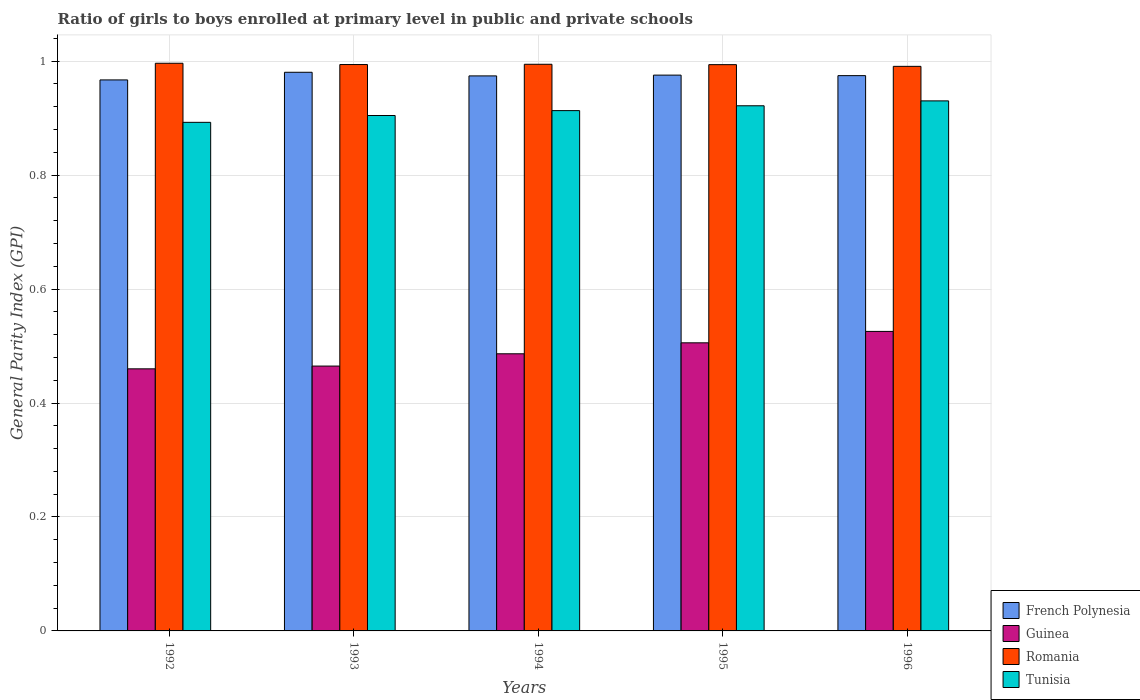How many groups of bars are there?
Offer a terse response. 5. Are the number of bars per tick equal to the number of legend labels?
Provide a succinct answer. Yes. Are the number of bars on each tick of the X-axis equal?
Your answer should be very brief. Yes. How many bars are there on the 3rd tick from the left?
Keep it short and to the point. 4. What is the label of the 3rd group of bars from the left?
Your answer should be very brief. 1994. What is the general parity index in French Polynesia in 1995?
Your answer should be compact. 0.98. Across all years, what is the maximum general parity index in French Polynesia?
Provide a short and direct response. 0.98. Across all years, what is the minimum general parity index in Guinea?
Make the answer very short. 0.46. What is the total general parity index in French Polynesia in the graph?
Your answer should be compact. 4.87. What is the difference between the general parity index in Guinea in 1993 and that in 1994?
Make the answer very short. -0.02. What is the difference between the general parity index in Guinea in 1994 and the general parity index in Tunisia in 1995?
Give a very brief answer. -0.44. What is the average general parity index in Tunisia per year?
Give a very brief answer. 0.91. In the year 1995, what is the difference between the general parity index in French Polynesia and general parity index in Tunisia?
Your answer should be very brief. 0.05. What is the ratio of the general parity index in Romania in 1993 to that in 1996?
Keep it short and to the point. 1. What is the difference between the highest and the second highest general parity index in French Polynesia?
Provide a short and direct response. 0. What is the difference between the highest and the lowest general parity index in Tunisia?
Your response must be concise. 0.04. Is the sum of the general parity index in Guinea in 1993 and 1996 greater than the maximum general parity index in Tunisia across all years?
Provide a succinct answer. Yes. Is it the case that in every year, the sum of the general parity index in Romania and general parity index in French Polynesia is greater than the sum of general parity index in Tunisia and general parity index in Guinea?
Your answer should be very brief. Yes. What does the 4th bar from the left in 1995 represents?
Make the answer very short. Tunisia. What does the 4th bar from the right in 1992 represents?
Ensure brevity in your answer.  French Polynesia. Is it the case that in every year, the sum of the general parity index in French Polynesia and general parity index in Guinea is greater than the general parity index in Tunisia?
Make the answer very short. Yes. How many bars are there?
Make the answer very short. 20. How many years are there in the graph?
Your answer should be compact. 5. What is the difference between two consecutive major ticks on the Y-axis?
Give a very brief answer. 0.2. Are the values on the major ticks of Y-axis written in scientific E-notation?
Offer a terse response. No. Does the graph contain any zero values?
Provide a succinct answer. No. Does the graph contain grids?
Your response must be concise. Yes. Where does the legend appear in the graph?
Make the answer very short. Bottom right. How many legend labels are there?
Your response must be concise. 4. How are the legend labels stacked?
Your answer should be compact. Vertical. What is the title of the graph?
Keep it short and to the point. Ratio of girls to boys enrolled at primary level in public and private schools. Does "Tunisia" appear as one of the legend labels in the graph?
Offer a very short reply. Yes. What is the label or title of the X-axis?
Offer a terse response. Years. What is the label or title of the Y-axis?
Make the answer very short. General Parity Index (GPI). What is the General Parity Index (GPI) in French Polynesia in 1992?
Ensure brevity in your answer.  0.97. What is the General Parity Index (GPI) of Guinea in 1992?
Offer a terse response. 0.46. What is the General Parity Index (GPI) of Romania in 1992?
Give a very brief answer. 1. What is the General Parity Index (GPI) of Tunisia in 1992?
Offer a very short reply. 0.89. What is the General Parity Index (GPI) in French Polynesia in 1993?
Keep it short and to the point. 0.98. What is the General Parity Index (GPI) in Guinea in 1993?
Offer a terse response. 0.46. What is the General Parity Index (GPI) in Romania in 1993?
Your answer should be very brief. 0.99. What is the General Parity Index (GPI) of Tunisia in 1993?
Give a very brief answer. 0.9. What is the General Parity Index (GPI) in French Polynesia in 1994?
Give a very brief answer. 0.97. What is the General Parity Index (GPI) of Guinea in 1994?
Your answer should be compact. 0.49. What is the General Parity Index (GPI) in Romania in 1994?
Offer a very short reply. 0.99. What is the General Parity Index (GPI) of Tunisia in 1994?
Offer a very short reply. 0.91. What is the General Parity Index (GPI) in French Polynesia in 1995?
Offer a very short reply. 0.98. What is the General Parity Index (GPI) in Guinea in 1995?
Make the answer very short. 0.51. What is the General Parity Index (GPI) of Romania in 1995?
Offer a very short reply. 0.99. What is the General Parity Index (GPI) of Tunisia in 1995?
Provide a succinct answer. 0.92. What is the General Parity Index (GPI) of French Polynesia in 1996?
Offer a terse response. 0.97. What is the General Parity Index (GPI) in Guinea in 1996?
Offer a very short reply. 0.53. What is the General Parity Index (GPI) in Romania in 1996?
Make the answer very short. 0.99. What is the General Parity Index (GPI) of Tunisia in 1996?
Provide a short and direct response. 0.93. Across all years, what is the maximum General Parity Index (GPI) in French Polynesia?
Your answer should be compact. 0.98. Across all years, what is the maximum General Parity Index (GPI) of Guinea?
Your response must be concise. 0.53. Across all years, what is the maximum General Parity Index (GPI) in Romania?
Give a very brief answer. 1. Across all years, what is the maximum General Parity Index (GPI) in Tunisia?
Provide a succinct answer. 0.93. Across all years, what is the minimum General Parity Index (GPI) of French Polynesia?
Keep it short and to the point. 0.97. Across all years, what is the minimum General Parity Index (GPI) in Guinea?
Make the answer very short. 0.46. Across all years, what is the minimum General Parity Index (GPI) in Romania?
Offer a terse response. 0.99. Across all years, what is the minimum General Parity Index (GPI) of Tunisia?
Provide a succinct answer. 0.89. What is the total General Parity Index (GPI) in French Polynesia in the graph?
Give a very brief answer. 4.87. What is the total General Parity Index (GPI) of Guinea in the graph?
Give a very brief answer. 2.44. What is the total General Parity Index (GPI) in Romania in the graph?
Provide a succinct answer. 4.97. What is the total General Parity Index (GPI) in Tunisia in the graph?
Your response must be concise. 4.56. What is the difference between the General Parity Index (GPI) in French Polynesia in 1992 and that in 1993?
Your response must be concise. -0.01. What is the difference between the General Parity Index (GPI) in Guinea in 1992 and that in 1993?
Keep it short and to the point. -0. What is the difference between the General Parity Index (GPI) in Romania in 1992 and that in 1993?
Keep it short and to the point. 0. What is the difference between the General Parity Index (GPI) of Tunisia in 1992 and that in 1993?
Ensure brevity in your answer.  -0.01. What is the difference between the General Parity Index (GPI) in French Polynesia in 1992 and that in 1994?
Provide a short and direct response. -0.01. What is the difference between the General Parity Index (GPI) in Guinea in 1992 and that in 1994?
Give a very brief answer. -0.03. What is the difference between the General Parity Index (GPI) of Romania in 1992 and that in 1994?
Your answer should be compact. 0. What is the difference between the General Parity Index (GPI) in Tunisia in 1992 and that in 1994?
Offer a terse response. -0.02. What is the difference between the General Parity Index (GPI) in French Polynesia in 1992 and that in 1995?
Make the answer very short. -0.01. What is the difference between the General Parity Index (GPI) in Guinea in 1992 and that in 1995?
Ensure brevity in your answer.  -0.05. What is the difference between the General Parity Index (GPI) of Romania in 1992 and that in 1995?
Ensure brevity in your answer.  0. What is the difference between the General Parity Index (GPI) of Tunisia in 1992 and that in 1995?
Your response must be concise. -0.03. What is the difference between the General Parity Index (GPI) of French Polynesia in 1992 and that in 1996?
Your response must be concise. -0.01. What is the difference between the General Parity Index (GPI) in Guinea in 1992 and that in 1996?
Give a very brief answer. -0.07. What is the difference between the General Parity Index (GPI) of Romania in 1992 and that in 1996?
Keep it short and to the point. 0.01. What is the difference between the General Parity Index (GPI) of Tunisia in 1992 and that in 1996?
Provide a succinct answer. -0.04. What is the difference between the General Parity Index (GPI) in French Polynesia in 1993 and that in 1994?
Provide a short and direct response. 0.01. What is the difference between the General Parity Index (GPI) of Guinea in 1993 and that in 1994?
Offer a very short reply. -0.02. What is the difference between the General Parity Index (GPI) of Romania in 1993 and that in 1994?
Provide a short and direct response. -0. What is the difference between the General Parity Index (GPI) of Tunisia in 1993 and that in 1994?
Your answer should be compact. -0.01. What is the difference between the General Parity Index (GPI) in French Polynesia in 1993 and that in 1995?
Ensure brevity in your answer.  0.01. What is the difference between the General Parity Index (GPI) in Guinea in 1993 and that in 1995?
Provide a short and direct response. -0.04. What is the difference between the General Parity Index (GPI) of Romania in 1993 and that in 1995?
Offer a terse response. 0. What is the difference between the General Parity Index (GPI) of Tunisia in 1993 and that in 1995?
Keep it short and to the point. -0.02. What is the difference between the General Parity Index (GPI) in French Polynesia in 1993 and that in 1996?
Make the answer very short. 0.01. What is the difference between the General Parity Index (GPI) of Guinea in 1993 and that in 1996?
Make the answer very short. -0.06. What is the difference between the General Parity Index (GPI) in Romania in 1993 and that in 1996?
Provide a succinct answer. 0. What is the difference between the General Parity Index (GPI) of Tunisia in 1993 and that in 1996?
Make the answer very short. -0.03. What is the difference between the General Parity Index (GPI) in French Polynesia in 1994 and that in 1995?
Your answer should be compact. -0. What is the difference between the General Parity Index (GPI) in Guinea in 1994 and that in 1995?
Keep it short and to the point. -0.02. What is the difference between the General Parity Index (GPI) of Romania in 1994 and that in 1995?
Offer a terse response. 0. What is the difference between the General Parity Index (GPI) of Tunisia in 1994 and that in 1995?
Your answer should be compact. -0.01. What is the difference between the General Parity Index (GPI) in French Polynesia in 1994 and that in 1996?
Offer a terse response. -0. What is the difference between the General Parity Index (GPI) of Guinea in 1994 and that in 1996?
Offer a very short reply. -0.04. What is the difference between the General Parity Index (GPI) of Romania in 1994 and that in 1996?
Keep it short and to the point. 0. What is the difference between the General Parity Index (GPI) of Tunisia in 1994 and that in 1996?
Provide a succinct answer. -0.02. What is the difference between the General Parity Index (GPI) in French Polynesia in 1995 and that in 1996?
Keep it short and to the point. 0. What is the difference between the General Parity Index (GPI) of Guinea in 1995 and that in 1996?
Your answer should be compact. -0.02. What is the difference between the General Parity Index (GPI) in Romania in 1995 and that in 1996?
Keep it short and to the point. 0. What is the difference between the General Parity Index (GPI) in Tunisia in 1995 and that in 1996?
Offer a very short reply. -0.01. What is the difference between the General Parity Index (GPI) of French Polynesia in 1992 and the General Parity Index (GPI) of Guinea in 1993?
Offer a very short reply. 0.5. What is the difference between the General Parity Index (GPI) in French Polynesia in 1992 and the General Parity Index (GPI) in Romania in 1993?
Your answer should be very brief. -0.03. What is the difference between the General Parity Index (GPI) in French Polynesia in 1992 and the General Parity Index (GPI) in Tunisia in 1993?
Make the answer very short. 0.06. What is the difference between the General Parity Index (GPI) of Guinea in 1992 and the General Parity Index (GPI) of Romania in 1993?
Ensure brevity in your answer.  -0.53. What is the difference between the General Parity Index (GPI) in Guinea in 1992 and the General Parity Index (GPI) in Tunisia in 1993?
Offer a very short reply. -0.44. What is the difference between the General Parity Index (GPI) in Romania in 1992 and the General Parity Index (GPI) in Tunisia in 1993?
Make the answer very short. 0.09. What is the difference between the General Parity Index (GPI) of French Polynesia in 1992 and the General Parity Index (GPI) of Guinea in 1994?
Offer a very short reply. 0.48. What is the difference between the General Parity Index (GPI) in French Polynesia in 1992 and the General Parity Index (GPI) in Romania in 1994?
Keep it short and to the point. -0.03. What is the difference between the General Parity Index (GPI) in French Polynesia in 1992 and the General Parity Index (GPI) in Tunisia in 1994?
Your response must be concise. 0.05. What is the difference between the General Parity Index (GPI) of Guinea in 1992 and the General Parity Index (GPI) of Romania in 1994?
Offer a terse response. -0.53. What is the difference between the General Parity Index (GPI) of Guinea in 1992 and the General Parity Index (GPI) of Tunisia in 1994?
Provide a succinct answer. -0.45. What is the difference between the General Parity Index (GPI) in Romania in 1992 and the General Parity Index (GPI) in Tunisia in 1994?
Keep it short and to the point. 0.08. What is the difference between the General Parity Index (GPI) in French Polynesia in 1992 and the General Parity Index (GPI) in Guinea in 1995?
Ensure brevity in your answer.  0.46. What is the difference between the General Parity Index (GPI) in French Polynesia in 1992 and the General Parity Index (GPI) in Romania in 1995?
Give a very brief answer. -0.03. What is the difference between the General Parity Index (GPI) of French Polynesia in 1992 and the General Parity Index (GPI) of Tunisia in 1995?
Offer a very short reply. 0.05. What is the difference between the General Parity Index (GPI) of Guinea in 1992 and the General Parity Index (GPI) of Romania in 1995?
Offer a very short reply. -0.53. What is the difference between the General Parity Index (GPI) of Guinea in 1992 and the General Parity Index (GPI) of Tunisia in 1995?
Your answer should be very brief. -0.46. What is the difference between the General Parity Index (GPI) of Romania in 1992 and the General Parity Index (GPI) of Tunisia in 1995?
Offer a very short reply. 0.07. What is the difference between the General Parity Index (GPI) of French Polynesia in 1992 and the General Parity Index (GPI) of Guinea in 1996?
Provide a short and direct response. 0.44. What is the difference between the General Parity Index (GPI) of French Polynesia in 1992 and the General Parity Index (GPI) of Romania in 1996?
Your answer should be compact. -0.02. What is the difference between the General Parity Index (GPI) of French Polynesia in 1992 and the General Parity Index (GPI) of Tunisia in 1996?
Your answer should be compact. 0.04. What is the difference between the General Parity Index (GPI) of Guinea in 1992 and the General Parity Index (GPI) of Romania in 1996?
Provide a short and direct response. -0.53. What is the difference between the General Parity Index (GPI) of Guinea in 1992 and the General Parity Index (GPI) of Tunisia in 1996?
Offer a very short reply. -0.47. What is the difference between the General Parity Index (GPI) in Romania in 1992 and the General Parity Index (GPI) in Tunisia in 1996?
Keep it short and to the point. 0.07. What is the difference between the General Parity Index (GPI) in French Polynesia in 1993 and the General Parity Index (GPI) in Guinea in 1994?
Offer a very short reply. 0.49. What is the difference between the General Parity Index (GPI) in French Polynesia in 1993 and the General Parity Index (GPI) in Romania in 1994?
Provide a short and direct response. -0.01. What is the difference between the General Parity Index (GPI) in French Polynesia in 1993 and the General Parity Index (GPI) in Tunisia in 1994?
Give a very brief answer. 0.07. What is the difference between the General Parity Index (GPI) in Guinea in 1993 and the General Parity Index (GPI) in Romania in 1994?
Give a very brief answer. -0.53. What is the difference between the General Parity Index (GPI) in Guinea in 1993 and the General Parity Index (GPI) in Tunisia in 1994?
Offer a terse response. -0.45. What is the difference between the General Parity Index (GPI) of Romania in 1993 and the General Parity Index (GPI) of Tunisia in 1994?
Provide a succinct answer. 0.08. What is the difference between the General Parity Index (GPI) in French Polynesia in 1993 and the General Parity Index (GPI) in Guinea in 1995?
Keep it short and to the point. 0.47. What is the difference between the General Parity Index (GPI) in French Polynesia in 1993 and the General Parity Index (GPI) in Romania in 1995?
Your answer should be compact. -0.01. What is the difference between the General Parity Index (GPI) of French Polynesia in 1993 and the General Parity Index (GPI) of Tunisia in 1995?
Give a very brief answer. 0.06. What is the difference between the General Parity Index (GPI) of Guinea in 1993 and the General Parity Index (GPI) of Romania in 1995?
Ensure brevity in your answer.  -0.53. What is the difference between the General Parity Index (GPI) of Guinea in 1993 and the General Parity Index (GPI) of Tunisia in 1995?
Provide a short and direct response. -0.46. What is the difference between the General Parity Index (GPI) of Romania in 1993 and the General Parity Index (GPI) of Tunisia in 1995?
Keep it short and to the point. 0.07. What is the difference between the General Parity Index (GPI) of French Polynesia in 1993 and the General Parity Index (GPI) of Guinea in 1996?
Provide a succinct answer. 0.45. What is the difference between the General Parity Index (GPI) of French Polynesia in 1993 and the General Parity Index (GPI) of Romania in 1996?
Make the answer very short. -0.01. What is the difference between the General Parity Index (GPI) in French Polynesia in 1993 and the General Parity Index (GPI) in Tunisia in 1996?
Your answer should be compact. 0.05. What is the difference between the General Parity Index (GPI) in Guinea in 1993 and the General Parity Index (GPI) in Romania in 1996?
Offer a terse response. -0.53. What is the difference between the General Parity Index (GPI) of Guinea in 1993 and the General Parity Index (GPI) of Tunisia in 1996?
Provide a short and direct response. -0.47. What is the difference between the General Parity Index (GPI) of Romania in 1993 and the General Parity Index (GPI) of Tunisia in 1996?
Provide a succinct answer. 0.06. What is the difference between the General Parity Index (GPI) of French Polynesia in 1994 and the General Parity Index (GPI) of Guinea in 1995?
Keep it short and to the point. 0.47. What is the difference between the General Parity Index (GPI) of French Polynesia in 1994 and the General Parity Index (GPI) of Romania in 1995?
Keep it short and to the point. -0.02. What is the difference between the General Parity Index (GPI) in French Polynesia in 1994 and the General Parity Index (GPI) in Tunisia in 1995?
Your response must be concise. 0.05. What is the difference between the General Parity Index (GPI) of Guinea in 1994 and the General Parity Index (GPI) of Romania in 1995?
Your response must be concise. -0.51. What is the difference between the General Parity Index (GPI) of Guinea in 1994 and the General Parity Index (GPI) of Tunisia in 1995?
Your answer should be compact. -0.44. What is the difference between the General Parity Index (GPI) in Romania in 1994 and the General Parity Index (GPI) in Tunisia in 1995?
Offer a very short reply. 0.07. What is the difference between the General Parity Index (GPI) in French Polynesia in 1994 and the General Parity Index (GPI) in Guinea in 1996?
Offer a very short reply. 0.45. What is the difference between the General Parity Index (GPI) in French Polynesia in 1994 and the General Parity Index (GPI) in Romania in 1996?
Your response must be concise. -0.02. What is the difference between the General Parity Index (GPI) in French Polynesia in 1994 and the General Parity Index (GPI) in Tunisia in 1996?
Your answer should be compact. 0.04. What is the difference between the General Parity Index (GPI) in Guinea in 1994 and the General Parity Index (GPI) in Romania in 1996?
Keep it short and to the point. -0.5. What is the difference between the General Parity Index (GPI) in Guinea in 1994 and the General Parity Index (GPI) in Tunisia in 1996?
Offer a terse response. -0.44. What is the difference between the General Parity Index (GPI) in Romania in 1994 and the General Parity Index (GPI) in Tunisia in 1996?
Give a very brief answer. 0.06. What is the difference between the General Parity Index (GPI) in French Polynesia in 1995 and the General Parity Index (GPI) in Guinea in 1996?
Keep it short and to the point. 0.45. What is the difference between the General Parity Index (GPI) in French Polynesia in 1995 and the General Parity Index (GPI) in Romania in 1996?
Your answer should be compact. -0.02. What is the difference between the General Parity Index (GPI) in French Polynesia in 1995 and the General Parity Index (GPI) in Tunisia in 1996?
Provide a short and direct response. 0.05. What is the difference between the General Parity Index (GPI) of Guinea in 1995 and the General Parity Index (GPI) of Romania in 1996?
Your answer should be very brief. -0.49. What is the difference between the General Parity Index (GPI) in Guinea in 1995 and the General Parity Index (GPI) in Tunisia in 1996?
Your answer should be very brief. -0.42. What is the difference between the General Parity Index (GPI) of Romania in 1995 and the General Parity Index (GPI) of Tunisia in 1996?
Give a very brief answer. 0.06. What is the average General Parity Index (GPI) of French Polynesia per year?
Your response must be concise. 0.97. What is the average General Parity Index (GPI) in Guinea per year?
Your answer should be very brief. 0.49. What is the average General Parity Index (GPI) of Romania per year?
Provide a short and direct response. 0.99. What is the average General Parity Index (GPI) of Tunisia per year?
Provide a short and direct response. 0.91. In the year 1992, what is the difference between the General Parity Index (GPI) of French Polynesia and General Parity Index (GPI) of Guinea?
Ensure brevity in your answer.  0.51. In the year 1992, what is the difference between the General Parity Index (GPI) of French Polynesia and General Parity Index (GPI) of Romania?
Make the answer very short. -0.03. In the year 1992, what is the difference between the General Parity Index (GPI) in French Polynesia and General Parity Index (GPI) in Tunisia?
Your answer should be very brief. 0.07. In the year 1992, what is the difference between the General Parity Index (GPI) in Guinea and General Parity Index (GPI) in Romania?
Your response must be concise. -0.54. In the year 1992, what is the difference between the General Parity Index (GPI) in Guinea and General Parity Index (GPI) in Tunisia?
Your response must be concise. -0.43. In the year 1992, what is the difference between the General Parity Index (GPI) of Romania and General Parity Index (GPI) of Tunisia?
Your response must be concise. 0.1. In the year 1993, what is the difference between the General Parity Index (GPI) in French Polynesia and General Parity Index (GPI) in Guinea?
Ensure brevity in your answer.  0.52. In the year 1993, what is the difference between the General Parity Index (GPI) of French Polynesia and General Parity Index (GPI) of Romania?
Keep it short and to the point. -0.01. In the year 1993, what is the difference between the General Parity Index (GPI) of French Polynesia and General Parity Index (GPI) of Tunisia?
Ensure brevity in your answer.  0.08. In the year 1993, what is the difference between the General Parity Index (GPI) of Guinea and General Parity Index (GPI) of Romania?
Provide a succinct answer. -0.53. In the year 1993, what is the difference between the General Parity Index (GPI) in Guinea and General Parity Index (GPI) in Tunisia?
Provide a succinct answer. -0.44. In the year 1993, what is the difference between the General Parity Index (GPI) of Romania and General Parity Index (GPI) of Tunisia?
Offer a terse response. 0.09. In the year 1994, what is the difference between the General Parity Index (GPI) in French Polynesia and General Parity Index (GPI) in Guinea?
Provide a succinct answer. 0.49. In the year 1994, what is the difference between the General Parity Index (GPI) of French Polynesia and General Parity Index (GPI) of Romania?
Provide a short and direct response. -0.02. In the year 1994, what is the difference between the General Parity Index (GPI) in French Polynesia and General Parity Index (GPI) in Tunisia?
Keep it short and to the point. 0.06. In the year 1994, what is the difference between the General Parity Index (GPI) of Guinea and General Parity Index (GPI) of Romania?
Make the answer very short. -0.51. In the year 1994, what is the difference between the General Parity Index (GPI) of Guinea and General Parity Index (GPI) of Tunisia?
Your answer should be compact. -0.43. In the year 1994, what is the difference between the General Parity Index (GPI) of Romania and General Parity Index (GPI) of Tunisia?
Offer a very short reply. 0.08. In the year 1995, what is the difference between the General Parity Index (GPI) of French Polynesia and General Parity Index (GPI) of Guinea?
Keep it short and to the point. 0.47. In the year 1995, what is the difference between the General Parity Index (GPI) of French Polynesia and General Parity Index (GPI) of Romania?
Provide a succinct answer. -0.02. In the year 1995, what is the difference between the General Parity Index (GPI) in French Polynesia and General Parity Index (GPI) in Tunisia?
Offer a very short reply. 0.05. In the year 1995, what is the difference between the General Parity Index (GPI) of Guinea and General Parity Index (GPI) of Romania?
Provide a short and direct response. -0.49. In the year 1995, what is the difference between the General Parity Index (GPI) in Guinea and General Parity Index (GPI) in Tunisia?
Make the answer very short. -0.42. In the year 1995, what is the difference between the General Parity Index (GPI) in Romania and General Parity Index (GPI) in Tunisia?
Ensure brevity in your answer.  0.07. In the year 1996, what is the difference between the General Parity Index (GPI) in French Polynesia and General Parity Index (GPI) in Guinea?
Your answer should be very brief. 0.45. In the year 1996, what is the difference between the General Parity Index (GPI) in French Polynesia and General Parity Index (GPI) in Romania?
Keep it short and to the point. -0.02. In the year 1996, what is the difference between the General Parity Index (GPI) in French Polynesia and General Parity Index (GPI) in Tunisia?
Provide a short and direct response. 0.04. In the year 1996, what is the difference between the General Parity Index (GPI) in Guinea and General Parity Index (GPI) in Romania?
Your answer should be very brief. -0.47. In the year 1996, what is the difference between the General Parity Index (GPI) of Guinea and General Parity Index (GPI) of Tunisia?
Provide a succinct answer. -0.4. In the year 1996, what is the difference between the General Parity Index (GPI) of Romania and General Parity Index (GPI) of Tunisia?
Give a very brief answer. 0.06. What is the ratio of the General Parity Index (GPI) of French Polynesia in 1992 to that in 1993?
Ensure brevity in your answer.  0.99. What is the ratio of the General Parity Index (GPI) of French Polynesia in 1992 to that in 1994?
Offer a very short reply. 0.99. What is the ratio of the General Parity Index (GPI) in Guinea in 1992 to that in 1994?
Your answer should be compact. 0.95. What is the ratio of the General Parity Index (GPI) of Tunisia in 1992 to that in 1994?
Your answer should be compact. 0.98. What is the ratio of the General Parity Index (GPI) in Guinea in 1992 to that in 1995?
Ensure brevity in your answer.  0.91. What is the ratio of the General Parity Index (GPI) in Romania in 1992 to that in 1995?
Your response must be concise. 1. What is the ratio of the General Parity Index (GPI) in Tunisia in 1992 to that in 1995?
Provide a short and direct response. 0.97. What is the ratio of the General Parity Index (GPI) of Guinea in 1992 to that in 1996?
Your response must be concise. 0.88. What is the ratio of the General Parity Index (GPI) of Tunisia in 1992 to that in 1996?
Keep it short and to the point. 0.96. What is the ratio of the General Parity Index (GPI) of Guinea in 1993 to that in 1994?
Your response must be concise. 0.96. What is the ratio of the General Parity Index (GPI) in Tunisia in 1993 to that in 1994?
Offer a very short reply. 0.99. What is the ratio of the General Parity Index (GPI) in Guinea in 1993 to that in 1995?
Your answer should be compact. 0.92. What is the ratio of the General Parity Index (GPI) of Romania in 1993 to that in 1995?
Your response must be concise. 1. What is the ratio of the General Parity Index (GPI) in Tunisia in 1993 to that in 1995?
Keep it short and to the point. 0.98. What is the ratio of the General Parity Index (GPI) of French Polynesia in 1993 to that in 1996?
Give a very brief answer. 1.01. What is the ratio of the General Parity Index (GPI) of Guinea in 1993 to that in 1996?
Ensure brevity in your answer.  0.88. What is the ratio of the General Parity Index (GPI) in Tunisia in 1993 to that in 1996?
Offer a terse response. 0.97. What is the ratio of the General Parity Index (GPI) in French Polynesia in 1994 to that in 1995?
Provide a short and direct response. 1. What is the ratio of the General Parity Index (GPI) of Guinea in 1994 to that in 1995?
Make the answer very short. 0.96. What is the ratio of the General Parity Index (GPI) of Romania in 1994 to that in 1995?
Provide a short and direct response. 1. What is the ratio of the General Parity Index (GPI) of Tunisia in 1994 to that in 1995?
Ensure brevity in your answer.  0.99. What is the ratio of the General Parity Index (GPI) of French Polynesia in 1994 to that in 1996?
Your answer should be very brief. 1. What is the ratio of the General Parity Index (GPI) in Guinea in 1994 to that in 1996?
Offer a terse response. 0.93. What is the ratio of the General Parity Index (GPI) of Romania in 1994 to that in 1996?
Provide a short and direct response. 1. What is the ratio of the General Parity Index (GPI) of Tunisia in 1994 to that in 1996?
Your answer should be very brief. 0.98. What is the ratio of the General Parity Index (GPI) in French Polynesia in 1995 to that in 1996?
Your response must be concise. 1. What is the ratio of the General Parity Index (GPI) in Guinea in 1995 to that in 1996?
Keep it short and to the point. 0.96. What is the difference between the highest and the second highest General Parity Index (GPI) in French Polynesia?
Your answer should be very brief. 0.01. What is the difference between the highest and the second highest General Parity Index (GPI) of Guinea?
Ensure brevity in your answer.  0.02. What is the difference between the highest and the second highest General Parity Index (GPI) in Romania?
Keep it short and to the point. 0. What is the difference between the highest and the second highest General Parity Index (GPI) in Tunisia?
Make the answer very short. 0.01. What is the difference between the highest and the lowest General Parity Index (GPI) of French Polynesia?
Provide a succinct answer. 0.01. What is the difference between the highest and the lowest General Parity Index (GPI) in Guinea?
Keep it short and to the point. 0.07. What is the difference between the highest and the lowest General Parity Index (GPI) of Romania?
Provide a short and direct response. 0.01. What is the difference between the highest and the lowest General Parity Index (GPI) of Tunisia?
Ensure brevity in your answer.  0.04. 